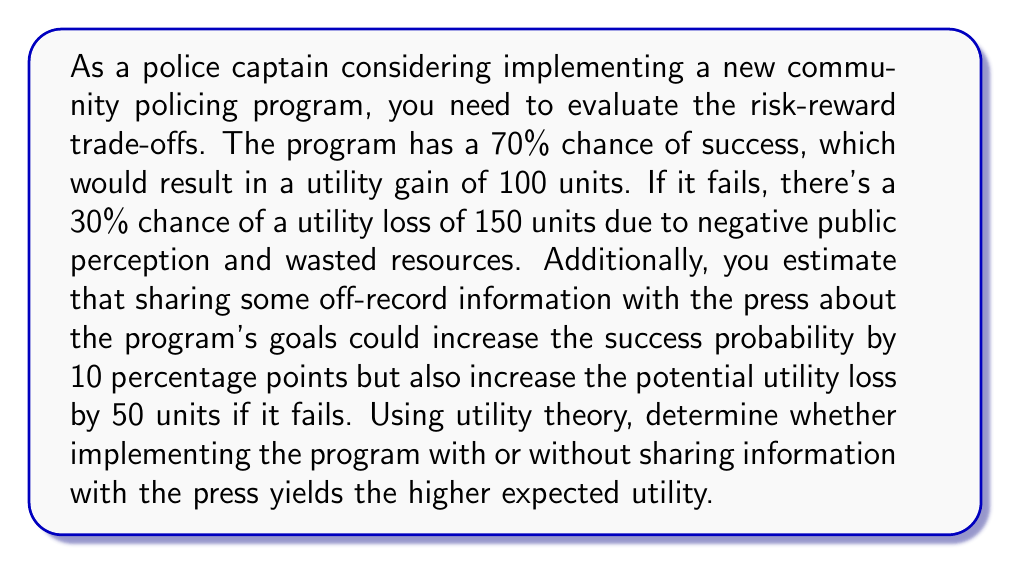Help me with this question. Let's approach this problem step-by-step using utility theory:

1. Calculate the expected utility of implementing the program without sharing information:

   $$ E(U_{without}) = 0.7 \times 100 + 0.3 \times (-150) $$
   $$ E(U_{without}) = 70 - 45 = 25 $$

2. Calculate the expected utility of implementing the program with sharing information:

   Success probability increases to 80%, and failure utility loss increases to 200 units.

   $$ E(U_{with}) = 0.8 \times 100 + 0.2 \times (-200) $$
   $$ E(U_{with}) = 80 - 40 = 40 $$

3. Compare the two expected utilities:

   $E(U_{with}) > E(U_{without})$
   $40 > 25$

The expected utility of implementing the program while sharing information with the press (40 units) is higher than implementing it without sharing information (25 units).

This result suggests that despite the increased potential loss, the higher probability of success when sharing information leads to a better overall expected outcome.
Answer: Implementing the program while sharing off-record information with the press yields the higher expected utility of 40 units, compared to 25 units without sharing information. 